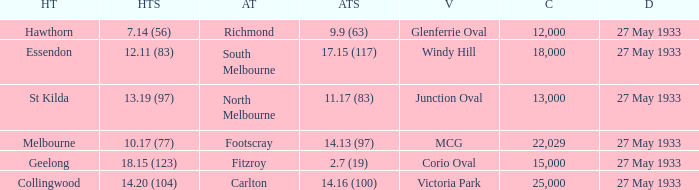Would you mind parsing the complete table? {'header': ['HT', 'HTS', 'AT', 'ATS', 'V', 'C', 'D'], 'rows': [['Hawthorn', '7.14 (56)', 'Richmond', '9.9 (63)', 'Glenferrie Oval', '12,000', '27 May 1933'], ['Essendon', '12.11 (83)', 'South Melbourne', '17.15 (117)', 'Windy Hill', '18,000', '27 May 1933'], ['St Kilda', '13.19 (97)', 'North Melbourne', '11.17 (83)', 'Junction Oval', '13,000', '27 May 1933'], ['Melbourne', '10.17 (77)', 'Footscray', '14.13 (97)', 'MCG', '22,029', '27 May 1933'], ['Geelong', '18.15 (123)', 'Fitzroy', '2.7 (19)', 'Corio Oval', '15,000', '27 May 1933'], ['Collingwood', '14.20 (104)', 'Carlton', '14.16 (100)', 'Victoria Park', '25,000', '27 May 1933']]} In the match where the away team scored 2.7 (19), how many peopel were in the crowd? 15000.0. 